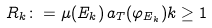Convert formula to latex. <formula><loc_0><loc_0><loc_500><loc_500>R _ { k } \colon = \mu ( E _ { k } ) \, a _ { T } ( \varphi _ { E _ { k } } ) k \geq 1</formula> 